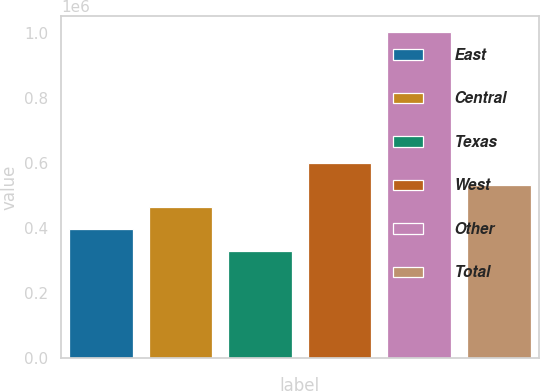Convert chart to OTSL. <chart><loc_0><loc_0><loc_500><loc_500><bar_chart><fcel>East<fcel>Central<fcel>Texas<fcel>West<fcel>Other<fcel>Total<nl><fcel>398200<fcel>465400<fcel>331000<fcel>599800<fcel>1.003e+06<fcel>532600<nl></chart> 